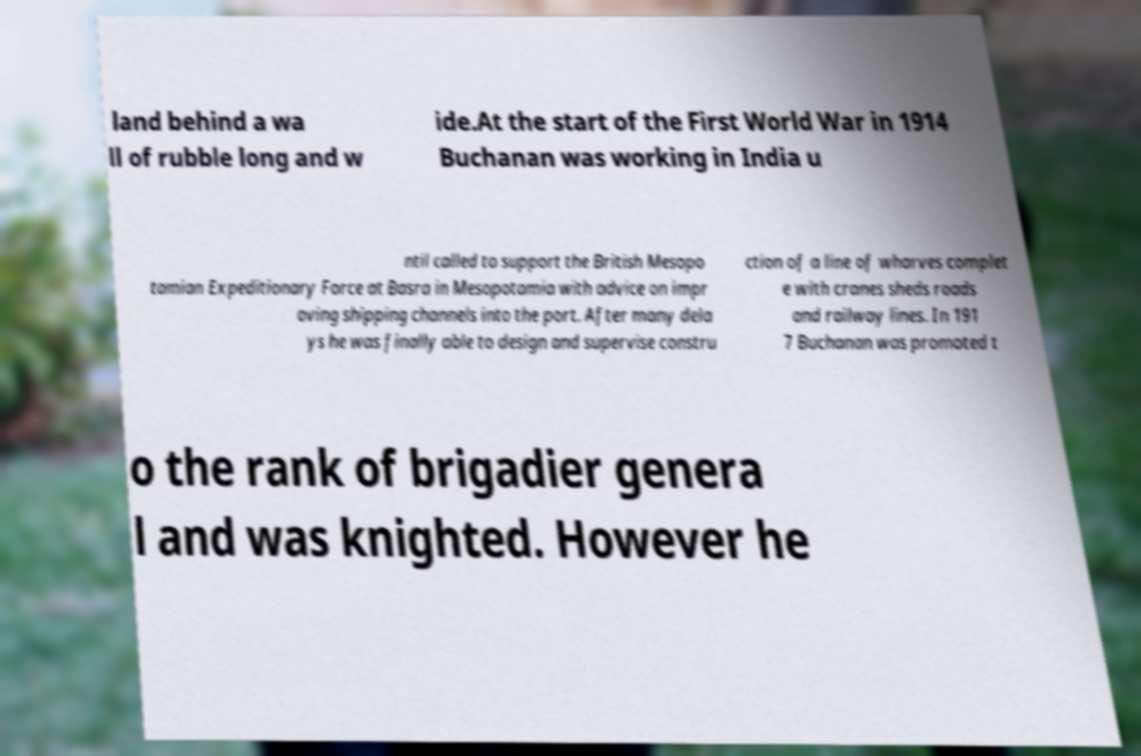Could you extract and type out the text from this image? land behind a wa ll of rubble long and w ide.At the start of the First World War in 1914 Buchanan was working in India u ntil called to support the British Mesopo tamian Expeditionary Force at Basra in Mesopotamia with advice on impr oving shipping channels into the port. After many dela ys he was finally able to design and supervise constru ction of a line of wharves complet e with cranes sheds roads and railway lines. In 191 7 Buchanan was promoted t o the rank of brigadier genera l and was knighted. However he 